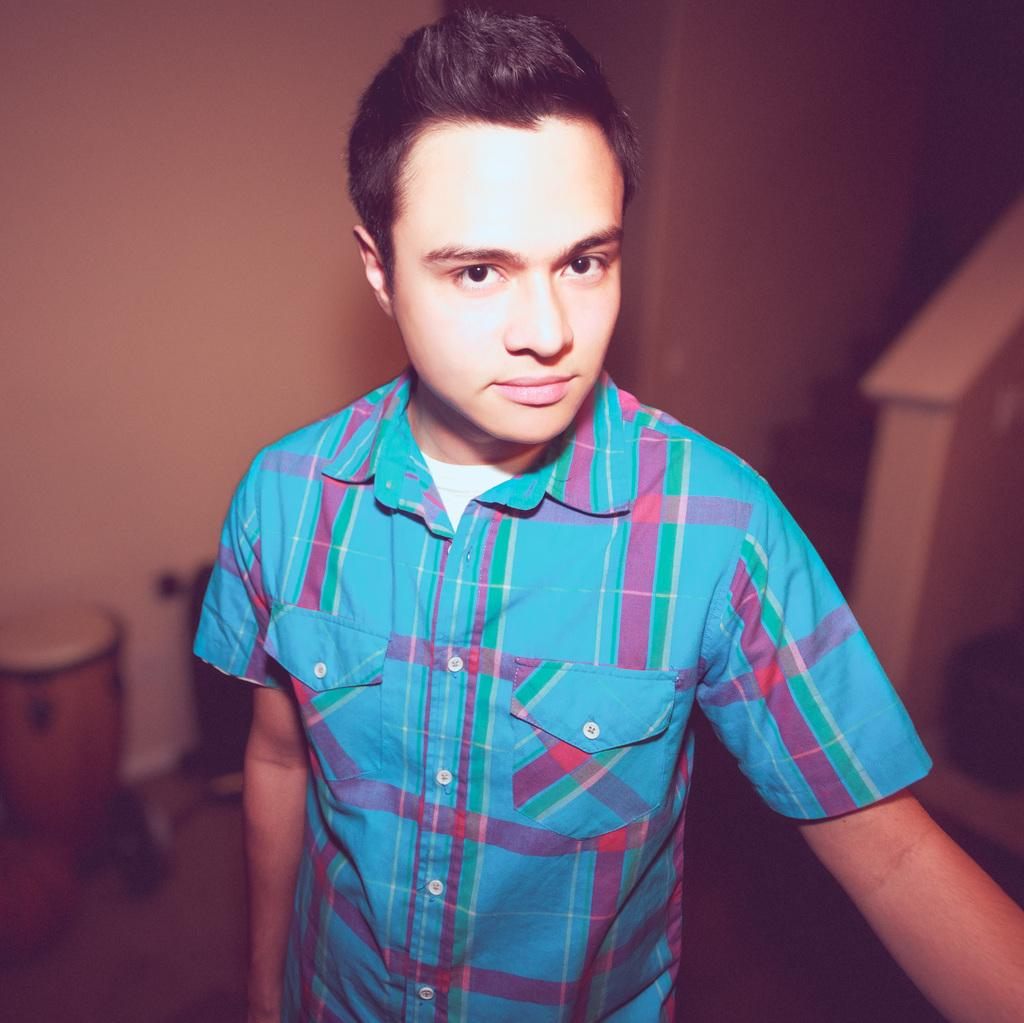What is the main subject of the image? There is a person in the image. What can be seen in the background of the image? There is a wall and objects in the background of the image. What type of spade is being used by the person in the image? There is no spade present in the image. What is the cause of death for the person in the image? There is no indication of death in the image, as the person appears to be alive and well. 